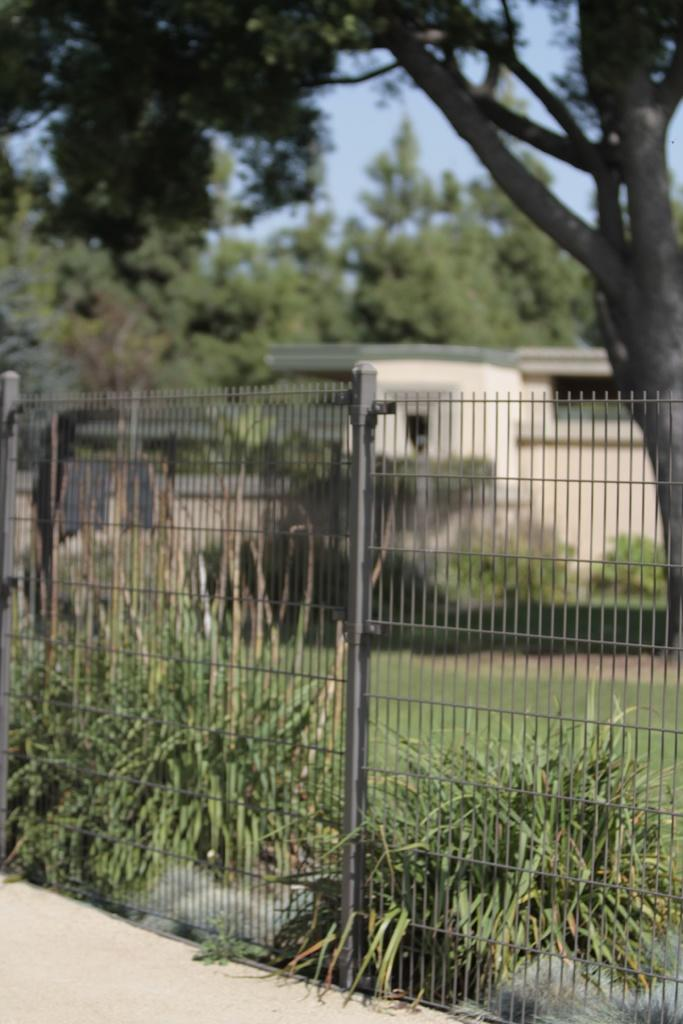What type of scene is depicted in the image? The image appears to be a fencing. What type of vegetation can be seen in the image? There are bushes and trees in the image. What is visible in the background of the image? There is a building in the background of the image. What type of fiction is being read by the trees in the image? There is no indication in the image that the trees are reading any fiction, as trees do not have the ability to read. 